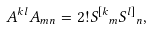<formula> <loc_0><loc_0><loc_500><loc_500>A { ^ { k } } { ^ { l } } A { _ { m } } { _ { n } } = 2 ! S { ^ { [ k } } { _ { m } } S { ^ { l ] } } { _ { n } } ,</formula> 